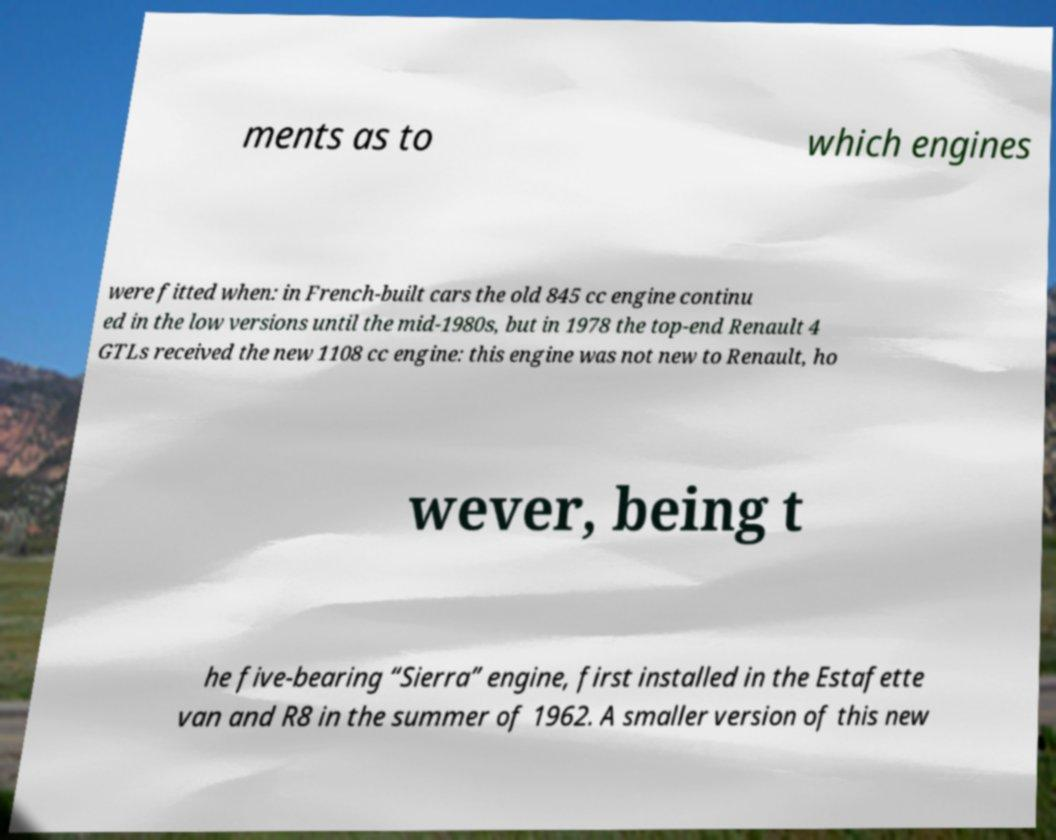Please identify and transcribe the text found in this image. ments as to which engines were fitted when: in French-built cars the old 845 cc engine continu ed in the low versions until the mid-1980s, but in 1978 the top-end Renault 4 GTLs received the new 1108 cc engine: this engine was not new to Renault, ho wever, being t he five-bearing “Sierra” engine, first installed in the Estafette van and R8 in the summer of 1962. A smaller version of this new 